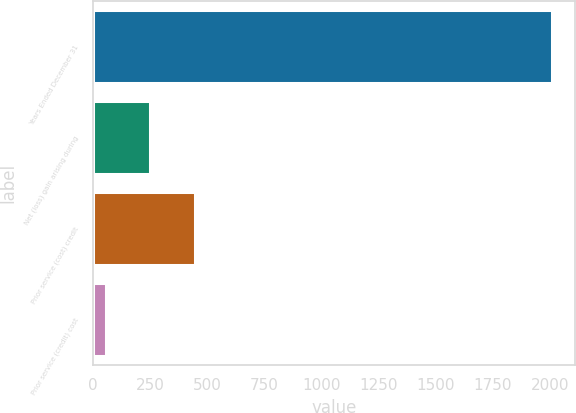Convert chart to OTSL. <chart><loc_0><loc_0><loc_500><loc_500><bar_chart><fcel>Years Ended December 31<fcel>Net (loss) gain arising during<fcel>Prior service (cost) credit<fcel>Prior service (credit) cost<nl><fcel>2011<fcel>250.6<fcel>446.2<fcel>55<nl></chart> 